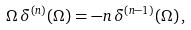Convert formula to latex. <formula><loc_0><loc_0><loc_500><loc_500>\Omega \, { \delta ^ { ( n ) } } ( \Omega ) = - n \, { \delta ^ { ( n - 1 ) } } ( \Omega ) \, ,</formula> 